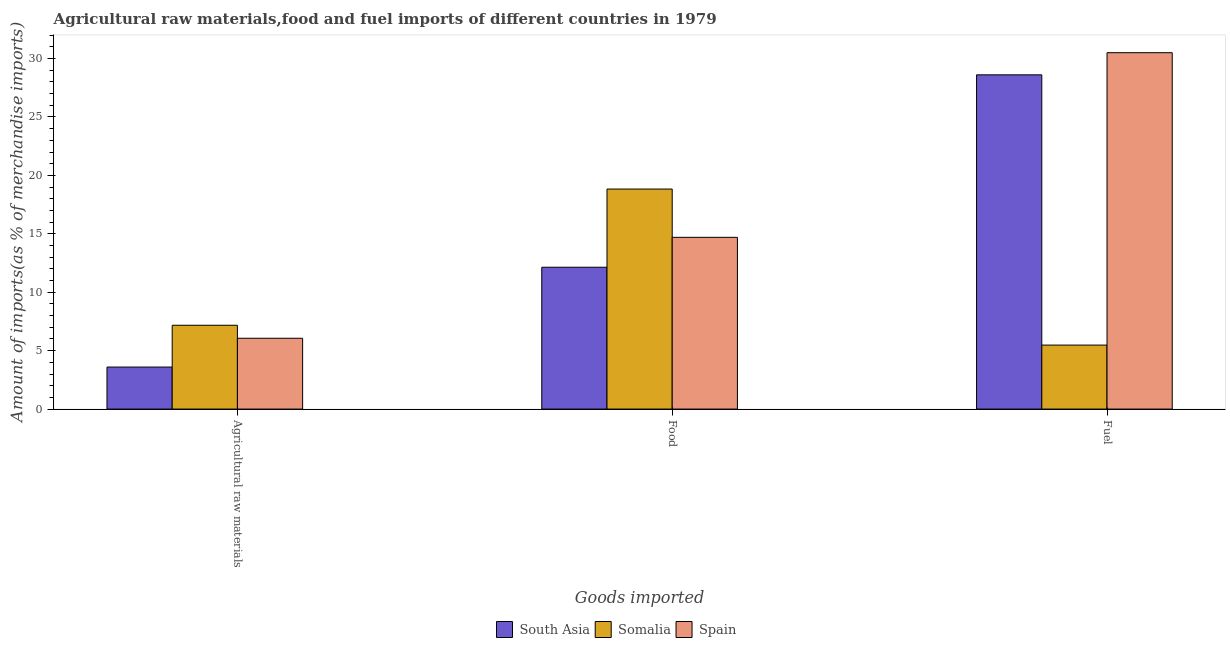Are the number of bars per tick equal to the number of legend labels?
Ensure brevity in your answer.  Yes. Are the number of bars on each tick of the X-axis equal?
Keep it short and to the point. Yes. How many bars are there on the 2nd tick from the left?
Your answer should be very brief. 3. What is the label of the 2nd group of bars from the left?
Give a very brief answer. Food. What is the percentage of food imports in South Asia?
Your response must be concise. 12.14. Across all countries, what is the maximum percentage of raw materials imports?
Your answer should be very brief. 7.17. Across all countries, what is the minimum percentage of fuel imports?
Ensure brevity in your answer.  5.48. In which country was the percentage of food imports maximum?
Keep it short and to the point. Somalia. What is the total percentage of raw materials imports in the graph?
Your answer should be very brief. 16.83. What is the difference between the percentage of raw materials imports in Spain and that in Somalia?
Offer a terse response. -1.11. What is the difference between the percentage of fuel imports in Spain and the percentage of raw materials imports in South Asia?
Ensure brevity in your answer.  26.91. What is the average percentage of fuel imports per country?
Keep it short and to the point. 21.53. What is the difference between the percentage of fuel imports and percentage of raw materials imports in Somalia?
Ensure brevity in your answer.  -1.7. What is the ratio of the percentage of fuel imports in Spain to that in Somalia?
Your response must be concise. 5.57. Is the percentage of food imports in South Asia less than that in Spain?
Ensure brevity in your answer.  Yes. Is the difference between the percentage of fuel imports in Spain and Somalia greater than the difference between the percentage of raw materials imports in Spain and Somalia?
Your response must be concise. Yes. What is the difference between the highest and the second highest percentage of food imports?
Provide a succinct answer. 4.13. What is the difference between the highest and the lowest percentage of raw materials imports?
Your response must be concise. 3.58. In how many countries, is the percentage of fuel imports greater than the average percentage of fuel imports taken over all countries?
Your answer should be very brief. 2. Is the sum of the percentage of raw materials imports in Spain and South Asia greater than the maximum percentage of fuel imports across all countries?
Provide a short and direct response. No. What does the 2nd bar from the left in Agricultural raw materials represents?
Your answer should be very brief. Somalia. Is it the case that in every country, the sum of the percentage of raw materials imports and percentage of food imports is greater than the percentage of fuel imports?
Offer a very short reply. No. How many bars are there?
Provide a succinct answer. 9. Are all the bars in the graph horizontal?
Your response must be concise. No. What is the difference between two consecutive major ticks on the Y-axis?
Provide a short and direct response. 5. Are the values on the major ticks of Y-axis written in scientific E-notation?
Offer a very short reply. No. Does the graph contain grids?
Provide a succinct answer. No. How are the legend labels stacked?
Your answer should be compact. Horizontal. What is the title of the graph?
Your answer should be compact. Agricultural raw materials,food and fuel imports of different countries in 1979. Does "Gabon" appear as one of the legend labels in the graph?
Your response must be concise. No. What is the label or title of the X-axis?
Keep it short and to the point. Goods imported. What is the label or title of the Y-axis?
Give a very brief answer. Amount of imports(as % of merchandise imports). What is the Amount of imports(as % of merchandise imports) in South Asia in Agricultural raw materials?
Offer a very short reply. 3.6. What is the Amount of imports(as % of merchandise imports) in Somalia in Agricultural raw materials?
Give a very brief answer. 7.17. What is the Amount of imports(as % of merchandise imports) in Spain in Agricultural raw materials?
Offer a very short reply. 6.06. What is the Amount of imports(as % of merchandise imports) of South Asia in Food?
Your response must be concise. 12.14. What is the Amount of imports(as % of merchandise imports) in Somalia in Food?
Ensure brevity in your answer.  18.83. What is the Amount of imports(as % of merchandise imports) of Spain in Food?
Ensure brevity in your answer.  14.7. What is the Amount of imports(as % of merchandise imports) of South Asia in Fuel?
Make the answer very short. 28.61. What is the Amount of imports(as % of merchandise imports) of Somalia in Fuel?
Ensure brevity in your answer.  5.48. What is the Amount of imports(as % of merchandise imports) in Spain in Fuel?
Your answer should be compact. 30.5. Across all Goods imported, what is the maximum Amount of imports(as % of merchandise imports) of South Asia?
Offer a terse response. 28.61. Across all Goods imported, what is the maximum Amount of imports(as % of merchandise imports) in Somalia?
Offer a terse response. 18.83. Across all Goods imported, what is the maximum Amount of imports(as % of merchandise imports) of Spain?
Your response must be concise. 30.5. Across all Goods imported, what is the minimum Amount of imports(as % of merchandise imports) of South Asia?
Your answer should be compact. 3.6. Across all Goods imported, what is the minimum Amount of imports(as % of merchandise imports) of Somalia?
Your response must be concise. 5.48. Across all Goods imported, what is the minimum Amount of imports(as % of merchandise imports) in Spain?
Ensure brevity in your answer.  6.06. What is the total Amount of imports(as % of merchandise imports) in South Asia in the graph?
Your response must be concise. 44.34. What is the total Amount of imports(as % of merchandise imports) of Somalia in the graph?
Give a very brief answer. 31.48. What is the total Amount of imports(as % of merchandise imports) in Spain in the graph?
Offer a very short reply. 51.26. What is the difference between the Amount of imports(as % of merchandise imports) in South Asia in Agricultural raw materials and that in Food?
Make the answer very short. -8.54. What is the difference between the Amount of imports(as % of merchandise imports) in Somalia in Agricultural raw materials and that in Food?
Your response must be concise. -11.66. What is the difference between the Amount of imports(as % of merchandise imports) of Spain in Agricultural raw materials and that in Food?
Offer a terse response. -8.64. What is the difference between the Amount of imports(as % of merchandise imports) in South Asia in Agricultural raw materials and that in Fuel?
Make the answer very short. -25.01. What is the difference between the Amount of imports(as % of merchandise imports) in Somalia in Agricultural raw materials and that in Fuel?
Provide a short and direct response. 1.7. What is the difference between the Amount of imports(as % of merchandise imports) of Spain in Agricultural raw materials and that in Fuel?
Give a very brief answer. -24.44. What is the difference between the Amount of imports(as % of merchandise imports) of South Asia in Food and that in Fuel?
Make the answer very short. -16.47. What is the difference between the Amount of imports(as % of merchandise imports) of Somalia in Food and that in Fuel?
Your response must be concise. 13.35. What is the difference between the Amount of imports(as % of merchandise imports) of Spain in Food and that in Fuel?
Keep it short and to the point. -15.8. What is the difference between the Amount of imports(as % of merchandise imports) in South Asia in Agricultural raw materials and the Amount of imports(as % of merchandise imports) in Somalia in Food?
Offer a very short reply. -15.23. What is the difference between the Amount of imports(as % of merchandise imports) of South Asia in Agricultural raw materials and the Amount of imports(as % of merchandise imports) of Spain in Food?
Your response must be concise. -11.1. What is the difference between the Amount of imports(as % of merchandise imports) of Somalia in Agricultural raw materials and the Amount of imports(as % of merchandise imports) of Spain in Food?
Give a very brief answer. -7.53. What is the difference between the Amount of imports(as % of merchandise imports) of South Asia in Agricultural raw materials and the Amount of imports(as % of merchandise imports) of Somalia in Fuel?
Ensure brevity in your answer.  -1.88. What is the difference between the Amount of imports(as % of merchandise imports) of South Asia in Agricultural raw materials and the Amount of imports(as % of merchandise imports) of Spain in Fuel?
Provide a short and direct response. -26.91. What is the difference between the Amount of imports(as % of merchandise imports) in Somalia in Agricultural raw materials and the Amount of imports(as % of merchandise imports) in Spain in Fuel?
Your answer should be very brief. -23.33. What is the difference between the Amount of imports(as % of merchandise imports) in South Asia in Food and the Amount of imports(as % of merchandise imports) in Somalia in Fuel?
Make the answer very short. 6.66. What is the difference between the Amount of imports(as % of merchandise imports) in South Asia in Food and the Amount of imports(as % of merchandise imports) in Spain in Fuel?
Your answer should be very brief. -18.36. What is the difference between the Amount of imports(as % of merchandise imports) in Somalia in Food and the Amount of imports(as % of merchandise imports) in Spain in Fuel?
Your answer should be compact. -11.67. What is the average Amount of imports(as % of merchandise imports) in South Asia per Goods imported?
Give a very brief answer. 14.78. What is the average Amount of imports(as % of merchandise imports) in Somalia per Goods imported?
Provide a short and direct response. 10.49. What is the average Amount of imports(as % of merchandise imports) in Spain per Goods imported?
Make the answer very short. 17.09. What is the difference between the Amount of imports(as % of merchandise imports) of South Asia and Amount of imports(as % of merchandise imports) of Somalia in Agricultural raw materials?
Give a very brief answer. -3.58. What is the difference between the Amount of imports(as % of merchandise imports) of South Asia and Amount of imports(as % of merchandise imports) of Spain in Agricultural raw materials?
Your response must be concise. -2.46. What is the difference between the Amount of imports(as % of merchandise imports) in Somalia and Amount of imports(as % of merchandise imports) in Spain in Agricultural raw materials?
Your answer should be very brief. 1.11. What is the difference between the Amount of imports(as % of merchandise imports) of South Asia and Amount of imports(as % of merchandise imports) of Somalia in Food?
Make the answer very short. -6.69. What is the difference between the Amount of imports(as % of merchandise imports) of South Asia and Amount of imports(as % of merchandise imports) of Spain in Food?
Offer a terse response. -2.56. What is the difference between the Amount of imports(as % of merchandise imports) of Somalia and Amount of imports(as % of merchandise imports) of Spain in Food?
Offer a terse response. 4.13. What is the difference between the Amount of imports(as % of merchandise imports) of South Asia and Amount of imports(as % of merchandise imports) of Somalia in Fuel?
Your answer should be compact. 23.13. What is the difference between the Amount of imports(as % of merchandise imports) in South Asia and Amount of imports(as % of merchandise imports) in Spain in Fuel?
Provide a succinct answer. -1.89. What is the difference between the Amount of imports(as % of merchandise imports) of Somalia and Amount of imports(as % of merchandise imports) of Spain in Fuel?
Make the answer very short. -25.03. What is the ratio of the Amount of imports(as % of merchandise imports) in South Asia in Agricultural raw materials to that in Food?
Ensure brevity in your answer.  0.3. What is the ratio of the Amount of imports(as % of merchandise imports) in Somalia in Agricultural raw materials to that in Food?
Your answer should be compact. 0.38. What is the ratio of the Amount of imports(as % of merchandise imports) of Spain in Agricultural raw materials to that in Food?
Your response must be concise. 0.41. What is the ratio of the Amount of imports(as % of merchandise imports) in South Asia in Agricultural raw materials to that in Fuel?
Your response must be concise. 0.13. What is the ratio of the Amount of imports(as % of merchandise imports) in Somalia in Agricultural raw materials to that in Fuel?
Provide a short and direct response. 1.31. What is the ratio of the Amount of imports(as % of merchandise imports) of Spain in Agricultural raw materials to that in Fuel?
Your answer should be very brief. 0.2. What is the ratio of the Amount of imports(as % of merchandise imports) of South Asia in Food to that in Fuel?
Offer a terse response. 0.42. What is the ratio of the Amount of imports(as % of merchandise imports) of Somalia in Food to that in Fuel?
Your answer should be very brief. 3.44. What is the ratio of the Amount of imports(as % of merchandise imports) in Spain in Food to that in Fuel?
Provide a short and direct response. 0.48. What is the difference between the highest and the second highest Amount of imports(as % of merchandise imports) in South Asia?
Ensure brevity in your answer.  16.47. What is the difference between the highest and the second highest Amount of imports(as % of merchandise imports) of Somalia?
Your answer should be very brief. 11.66. What is the difference between the highest and the second highest Amount of imports(as % of merchandise imports) of Spain?
Your answer should be very brief. 15.8. What is the difference between the highest and the lowest Amount of imports(as % of merchandise imports) in South Asia?
Keep it short and to the point. 25.01. What is the difference between the highest and the lowest Amount of imports(as % of merchandise imports) of Somalia?
Provide a short and direct response. 13.35. What is the difference between the highest and the lowest Amount of imports(as % of merchandise imports) of Spain?
Ensure brevity in your answer.  24.44. 